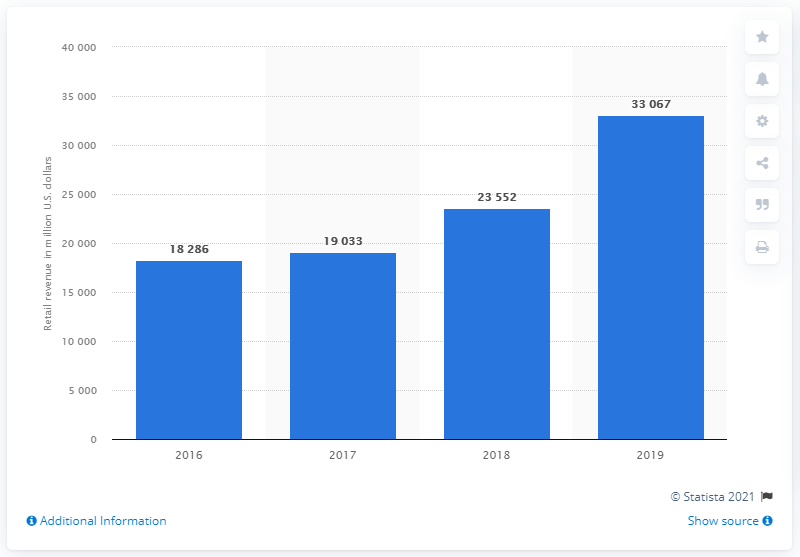Indicate a few pertinent items in this graphic. In 2019, Speedway generated approximately $330,670 in retail revenue in the United States. 